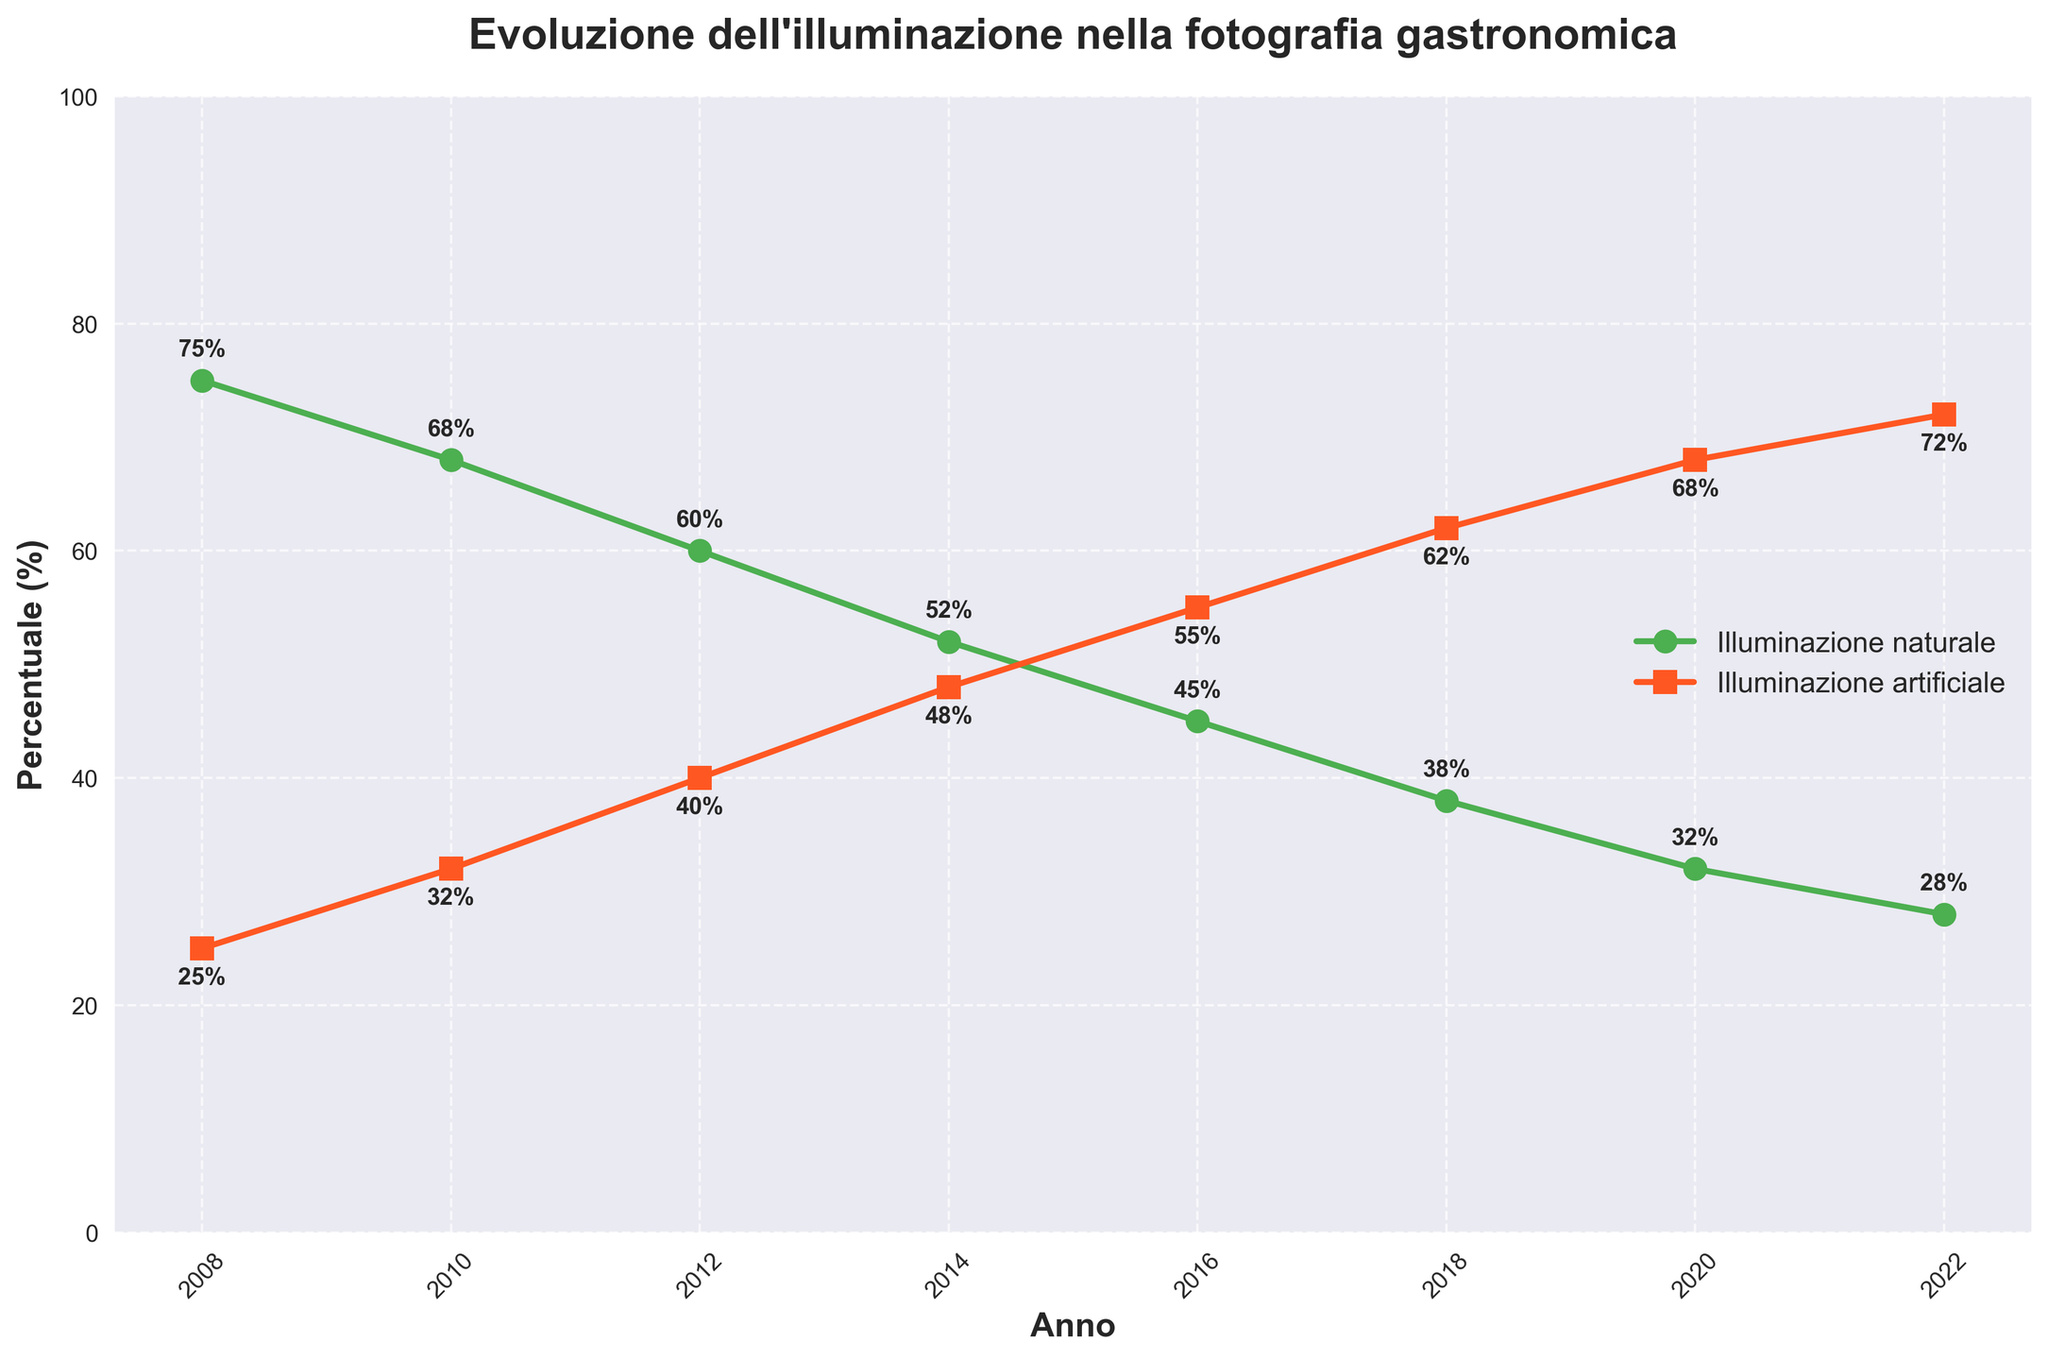**Domanda 1** **Spiegazione**
Answer: **Risposta Concisa** Domanda: Qual è stata la variazione percentuale di utilizzo dell'illuminazione naturale tra il 2008 e il 2022? Spiegazione: Per calcolare la variazione percentuale, sottrai il valore di fine (28%) dal valore di inizio (75%) e poi dividi per il valore di inizio. Infine, moltiplica per 100. (($28 - 75$) / 75) * 100 = -62.67%
Answer: -62.67% Domanda: Quale anno ha visto l'utilizzo dell'illuminazione artificiale superare quello dell'illuminazione naturale? Spiegazione: L'anno in cui l'illuminazione artificiale ha superato quella naturale è il 2016, quando l'utilizzo dell'illuminazione artificiale è diventato il 55%, mentre quello naturale è sceso al 45%.
Answer: 2016 Domanda: Qual è stata la differenza tra l'uso di illuminazione artificiale e naturale nel 2022? Spiegazione: La differenza nell'utilizzo tra i due tipi di illuminazione nel 2022 è di 72% - 28% = 44%.
Answer: 44% Domanda: In quale anno l'uso dell'illuminazione naturale è sceso sotto il 50% per la prima volta? Spiegazione: Nel 2014, l'uso dell'illuminazione naturale è sceso al 52%, e nel successivo intervallo di dati del 2016 è sceso al 45%, quindi la prima volta è stata nel 2016.
Answer: 2016 Domanda: Qual è il trend generale dell'utilizzo dell'illuminazione naturale negli ultimi 15 anni? Spiegazione: Il trend generale mostra una diminuzione costante dell'uso dell'illuminazione naturale dal 75% nel 2008 al 28% nel 2022.
Answer: Diminuzione Domanda: Qual è la somma totale delle percentuali di illuminazione naturale e artificiale nel 2010? Spiegazione: La somma delle percentuali di illuminazione naturale (68%) e artificiale (32%) nel 2010 è 68 + 32.
Answer: 100% Domanda: Quale tipo di illuminazione ha subito l'aumento percentuale maggiore dal 2008 al 2022? Spiegazione: Tra i due tipi di illuminazione, l'illuminazione artificiale è passata dal 25% al 72%, rappresentando un aumento di 47%.
Answer: Illuminazione artificiale Domanda: Nel 2018, l'utilizzo dell'illuminazione artificiale era più o meno del doppio rispetto a quello naturale? Spiegazione: Nel 2018, l'utilizzo dell'illuminazione artificiale era del 62%, e quello naturale del 38%. Il 62% è più movimento del doppio del 38%.
Answer: Più del doppio Domanda: Di quanto è diminuito l'uso di illuminazione naturale dal 2010 al 2014? Spiegazione: La diminuzione tra il 2010 (68%) e il 2014 (52%) è calcolata sottraendo 52 da 68.
Answer: 16% Domanda: In quale anno l'uso di illuminazione naturale e artificiale si sono più avvicinati? Spiegazione: Nel 2014, l'illuminazione naturale era al 52% e quella artificiale al 48%, differenza minima tra i due (4%).
Answer: 2014 